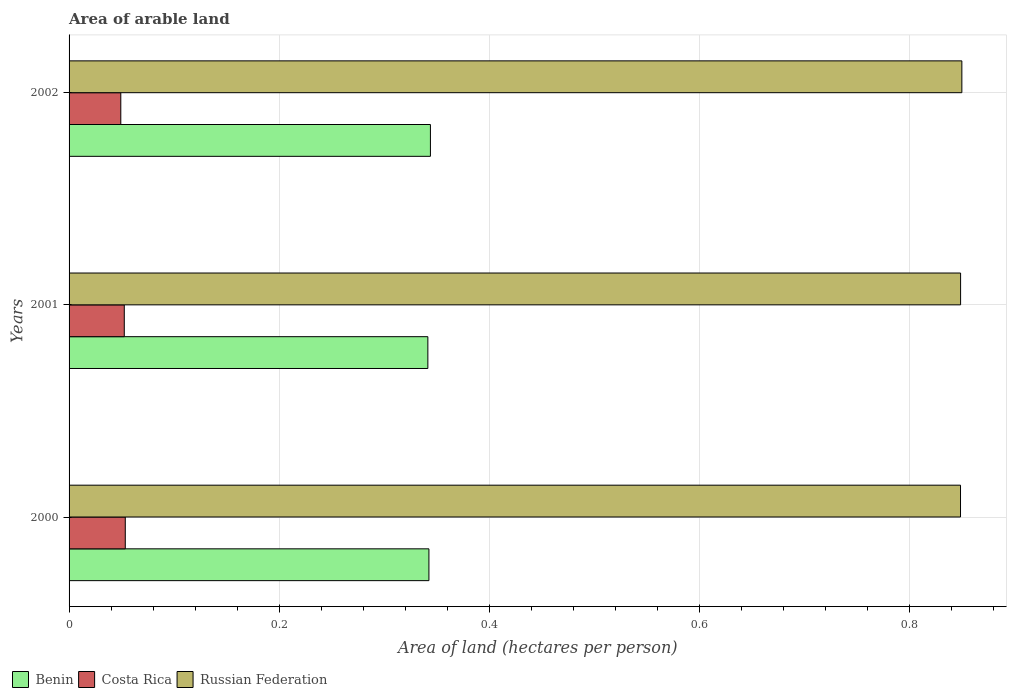Are the number of bars per tick equal to the number of legend labels?
Provide a short and direct response. Yes. Are the number of bars on each tick of the Y-axis equal?
Give a very brief answer. Yes. In how many cases, is the number of bars for a given year not equal to the number of legend labels?
Ensure brevity in your answer.  0. What is the total arable land in Costa Rica in 2002?
Make the answer very short. 0.05. Across all years, what is the maximum total arable land in Russian Federation?
Make the answer very short. 0.85. Across all years, what is the minimum total arable land in Russian Federation?
Keep it short and to the point. 0.85. What is the total total arable land in Benin in the graph?
Provide a short and direct response. 1.03. What is the difference between the total arable land in Costa Rica in 2000 and that in 2001?
Make the answer very short. 0. What is the difference between the total arable land in Russian Federation in 2000 and the total arable land in Costa Rica in 2002?
Give a very brief answer. 0.8. What is the average total arable land in Russian Federation per year?
Your answer should be compact. 0.85. In the year 2000, what is the difference between the total arable land in Benin and total arable land in Costa Rica?
Your answer should be compact. 0.29. In how many years, is the total arable land in Russian Federation greater than 0.6400000000000001 hectares per person?
Provide a succinct answer. 3. What is the ratio of the total arable land in Costa Rica in 2001 to that in 2002?
Keep it short and to the point. 1.07. What is the difference between the highest and the second highest total arable land in Russian Federation?
Your answer should be very brief. 0. What is the difference between the highest and the lowest total arable land in Costa Rica?
Your response must be concise. 0. In how many years, is the total arable land in Costa Rica greater than the average total arable land in Costa Rica taken over all years?
Your answer should be compact. 2. What does the 1st bar from the top in 2002 represents?
Keep it short and to the point. Russian Federation. What does the 3rd bar from the bottom in 2002 represents?
Keep it short and to the point. Russian Federation. Is it the case that in every year, the sum of the total arable land in Russian Federation and total arable land in Costa Rica is greater than the total arable land in Benin?
Offer a very short reply. Yes. How many bars are there?
Your answer should be compact. 9. How many years are there in the graph?
Provide a succinct answer. 3. Does the graph contain grids?
Your response must be concise. Yes. How are the legend labels stacked?
Your response must be concise. Horizontal. What is the title of the graph?
Your answer should be compact. Area of arable land. Does "Mexico" appear as one of the legend labels in the graph?
Make the answer very short. No. What is the label or title of the X-axis?
Your answer should be compact. Area of land (hectares per person). What is the label or title of the Y-axis?
Offer a very short reply. Years. What is the Area of land (hectares per person) in Benin in 2000?
Your answer should be very brief. 0.34. What is the Area of land (hectares per person) in Costa Rica in 2000?
Your answer should be very brief. 0.05. What is the Area of land (hectares per person) of Russian Federation in 2000?
Make the answer very short. 0.85. What is the Area of land (hectares per person) of Benin in 2001?
Your answer should be very brief. 0.34. What is the Area of land (hectares per person) in Costa Rica in 2001?
Offer a terse response. 0.05. What is the Area of land (hectares per person) in Russian Federation in 2001?
Provide a succinct answer. 0.85. What is the Area of land (hectares per person) in Benin in 2002?
Give a very brief answer. 0.34. What is the Area of land (hectares per person) of Costa Rica in 2002?
Provide a succinct answer. 0.05. What is the Area of land (hectares per person) in Russian Federation in 2002?
Your answer should be compact. 0.85. Across all years, what is the maximum Area of land (hectares per person) of Benin?
Offer a terse response. 0.34. Across all years, what is the maximum Area of land (hectares per person) of Costa Rica?
Ensure brevity in your answer.  0.05. Across all years, what is the maximum Area of land (hectares per person) of Russian Federation?
Offer a terse response. 0.85. Across all years, what is the minimum Area of land (hectares per person) in Benin?
Provide a short and direct response. 0.34. Across all years, what is the minimum Area of land (hectares per person) of Costa Rica?
Provide a short and direct response. 0.05. Across all years, what is the minimum Area of land (hectares per person) of Russian Federation?
Make the answer very short. 0.85. What is the total Area of land (hectares per person) in Benin in the graph?
Your answer should be very brief. 1.03. What is the total Area of land (hectares per person) of Costa Rica in the graph?
Your answer should be compact. 0.16. What is the total Area of land (hectares per person) of Russian Federation in the graph?
Provide a short and direct response. 2.55. What is the difference between the Area of land (hectares per person) in Russian Federation in 2000 and that in 2001?
Keep it short and to the point. -0. What is the difference between the Area of land (hectares per person) in Benin in 2000 and that in 2002?
Your response must be concise. -0. What is the difference between the Area of land (hectares per person) of Costa Rica in 2000 and that in 2002?
Offer a terse response. 0. What is the difference between the Area of land (hectares per person) in Russian Federation in 2000 and that in 2002?
Your answer should be compact. -0. What is the difference between the Area of land (hectares per person) in Benin in 2001 and that in 2002?
Your response must be concise. -0. What is the difference between the Area of land (hectares per person) in Costa Rica in 2001 and that in 2002?
Provide a succinct answer. 0. What is the difference between the Area of land (hectares per person) in Russian Federation in 2001 and that in 2002?
Offer a terse response. -0. What is the difference between the Area of land (hectares per person) in Benin in 2000 and the Area of land (hectares per person) in Costa Rica in 2001?
Offer a very short reply. 0.29. What is the difference between the Area of land (hectares per person) in Benin in 2000 and the Area of land (hectares per person) in Russian Federation in 2001?
Provide a succinct answer. -0.51. What is the difference between the Area of land (hectares per person) of Costa Rica in 2000 and the Area of land (hectares per person) of Russian Federation in 2001?
Your answer should be compact. -0.8. What is the difference between the Area of land (hectares per person) in Benin in 2000 and the Area of land (hectares per person) in Costa Rica in 2002?
Your response must be concise. 0.29. What is the difference between the Area of land (hectares per person) in Benin in 2000 and the Area of land (hectares per person) in Russian Federation in 2002?
Keep it short and to the point. -0.51. What is the difference between the Area of land (hectares per person) of Costa Rica in 2000 and the Area of land (hectares per person) of Russian Federation in 2002?
Ensure brevity in your answer.  -0.8. What is the difference between the Area of land (hectares per person) in Benin in 2001 and the Area of land (hectares per person) in Costa Rica in 2002?
Your response must be concise. 0.29. What is the difference between the Area of land (hectares per person) of Benin in 2001 and the Area of land (hectares per person) of Russian Federation in 2002?
Provide a short and direct response. -0.51. What is the difference between the Area of land (hectares per person) in Costa Rica in 2001 and the Area of land (hectares per person) in Russian Federation in 2002?
Offer a terse response. -0.8. What is the average Area of land (hectares per person) of Benin per year?
Make the answer very short. 0.34. What is the average Area of land (hectares per person) in Costa Rica per year?
Your answer should be very brief. 0.05. What is the average Area of land (hectares per person) in Russian Federation per year?
Give a very brief answer. 0.85. In the year 2000, what is the difference between the Area of land (hectares per person) of Benin and Area of land (hectares per person) of Costa Rica?
Keep it short and to the point. 0.29. In the year 2000, what is the difference between the Area of land (hectares per person) of Benin and Area of land (hectares per person) of Russian Federation?
Make the answer very short. -0.51. In the year 2000, what is the difference between the Area of land (hectares per person) in Costa Rica and Area of land (hectares per person) in Russian Federation?
Give a very brief answer. -0.79. In the year 2001, what is the difference between the Area of land (hectares per person) of Benin and Area of land (hectares per person) of Costa Rica?
Your answer should be very brief. 0.29. In the year 2001, what is the difference between the Area of land (hectares per person) of Benin and Area of land (hectares per person) of Russian Federation?
Make the answer very short. -0.51. In the year 2001, what is the difference between the Area of land (hectares per person) in Costa Rica and Area of land (hectares per person) in Russian Federation?
Offer a terse response. -0.8. In the year 2002, what is the difference between the Area of land (hectares per person) in Benin and Area of land (hectares per person) in Costa Rica?
Provide a succinct answer. 0.29. In the year 2002, what is the difference between the Area of land (hectares per person) in Benin and Area of land (hectares per person) in Russian Federation?
Your answer should be very brief. -0.51. In the year 2002, what is the difference between the Area of land (hectares per person) of Costa Rica and Area of land (hectares per person) of Russian Federation?
Your answer should be very brief. -0.8. What is the ratio of the Area of land (hectares per person) of Benin in 2000 to that in 2001?
Give a very brief answer. 1. What is the ratio of the Area of land (hectares per person) of Costa Rica in 2000 to that in 2001?
Give a very brief answer. 1.02. What is the ratio of the Area of land (hectares per person) in Russian Federation in 2000 to that in 2001?
Offer a very short reply. 1. What is the ratio of the Area of land (hectares per person) in Benin in 2000 to that in 2002?
Give a very brief answer. 1. What is the ratio of the Area of land (hectares per person) of Costa Rica in 2000 to that in 2002?
Make the answer very short. 1.09. What is the ratio of the Area of land (hectares per person) in Russian Federation in 2000 to that in 2002?
Ensure brevity in your answer.  1. What is the ratio of the Area of land (hectares per person) of Costa Rica in 2001 to that in 2002?
Make the answer very short. 1.07. What is the ratio of the Area of land (hectares per person) in Russian Federation in 2001 to that in 2002?
Your response must be concise. 1. What is the difference between the highest and the second highest Area of land (hectares per person) of Benin?
Offer a very short reply. 0. What is the difference between the highest and the second highest Area of land (hectares per person) of Costa Rica?
Make the answer very short. 0. What is the difference between the highest and the second highest Area of land (hectares per person) of Russian Federation?
Your answer should be compact. 0. What is the difference between the highest and the lowest Area of land (hectares per person) of Benin?
Your answer should be compact. 0. What is the difference between the highest and the lowest Area of land (hectares per person) in Costa Rica?
Your answer should be compact. 0. What is the difference between the highest and the lowest Area of land (hectares per person) in Russian Federation?
Offer a very short reply. 0. 